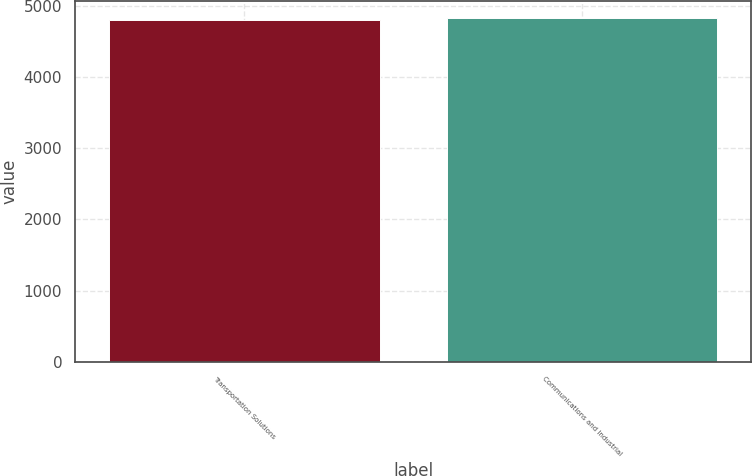Convert chart. <chart><loc_0><loc_0><loc_500><loc_500><bar_chart><fcel>Transportation Solutions<fcel>Communications and Industrial<nl><fcel>4799<fcel>4820<nl></chart> 